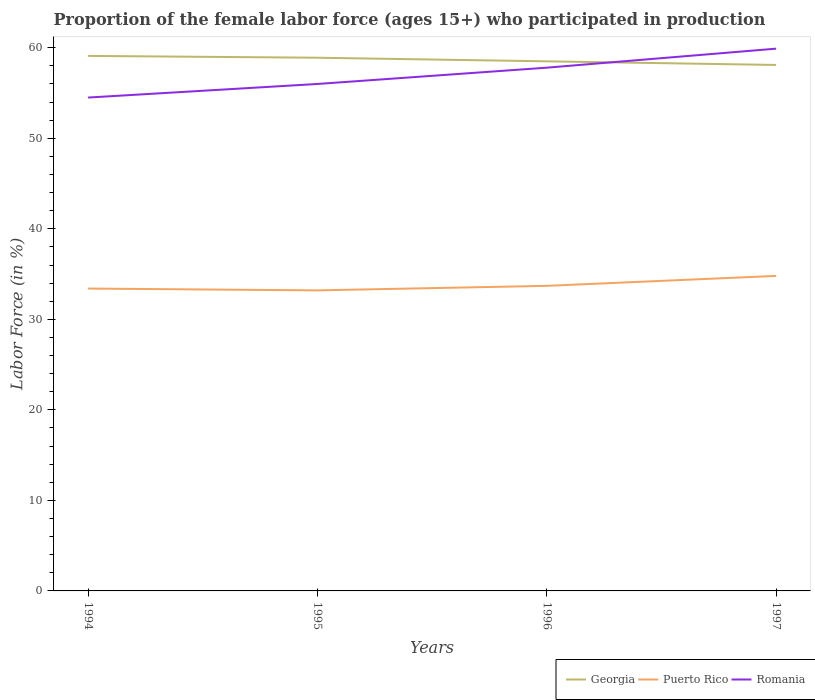Is the number of lines equal to the number of legend labels?
Offer a terse response. Yes. Across all years, what is the maximum proportion of the female labor force who participated in production in Puerto Rico?
Ensure brevity in your answer.  33.2. What is the total proportion of the female labor force who participated in production in Puerto Rico in the graph?
Ensure brevity in your answer.  -1.1. What is the difference between the highest and the second highest proportion of the female labor force who participated in production in Georgia?
Offer a terse response. 1. What is the difference between the highest and the lowest proportion of the female labor force who participated in production in Puerto Rico?
Ensure brevity in your answer.  1. Is the proportion of the female labor force who participated in production in Puerto Rico strictly greater than the proportion of the female labor force who participated in production in Georgia over the years?
Give a very brief answer. Yes. How many lines are there?
Provide a succinct answer. 3. What is the difference between two consecutive major ticks on the Y-axis?
Provide a short and direct response. 10. Are the values on the major ticks of Y-axis written in scientific E-notation?
Your answer should be compact. No. Does the graph contain any zero values?
Ensure brevity in your answer.  No. Does the graph contain grids?
Give a very brief answer. No. Where does the legend appear in the graph?
Ensure brevity in your answer.  Bottom right. How many legend labels are there?
Your response must be concise. 3. What is the title of the graph?
Your answer should be compact. Proportion of the female labor force (ages 15+) who participated in production. What is the Labor Force (in %) in Georgia in 1994?
Give a very brief answer. 59.1. What is the Labor Force (in %) of Puerto Rico in 1994?
Give a very brief answer. 33.4. What is the Labor Force (in %) of Romania in 1994?
Keep it short and to the point. 54.5. What is the Labor Force (in %) of Georgia in 1995?
Ensure brevity in your answer.  58.9. What is the Labor Force (in %) of Puerto Rico in 1995?
Offer a very short reply. 33.2. What is the Labor Force (in %) in Georgia in 1996?
Make the answer very short. 58.5. What is the Labor Force (in %) in Puerto Rico in 1996?
Ensure brevity in your answer.  33.7. What is the Labor Force (in %) of Romania in 1996?
Keep it short and to the point. 57.8. What is the Labor Force (in %) of Georgia in 1997?
Your answer should be compact. 58.1. What is the Labor Force (in %) in Puerto Rico in 1997?
Offer a very short reply. 34.8. What is the Labor Force (in %) of Romania in 1997?
Offer a very short reply. 59.9. Across all years, what is the maximum Labor Force (in %) in Georgia?
Your answer should be compact. 59.1. Across all years, what is the maximum Labor Force (in %) in Puerto Rico?
Keep it short and to the point. 34.8. Across all years, what is the maximum Labor Force (in %) in Romania?
Make the answer very short. 59.9. Across all years, what is the minimum Labor Force (in %) in Georgia?
Keep it short and to the point. 58.1. Across all years, what is the minimum Labor Force (in %) in Puerto Rico?
Your response must be concise. 33.2. Across all years, what is the minimum Labor Force (in %) in Romania?
Provide a short and direct response. 54.5. What is the total Labor Force (in %) in Georgia in the graph?
Give a very brief answer. 234.6. What is the total Labor Force (in %) in Puerto Rico in the graph?
Offer a very short reply. 135.1. What is the total Labor Force (in %) in Romania in the graph?
Your answer should be very brief. 228.2. What is the difference between the Labor Force (in %) of Puerto Rico in 1994 and that in 1997?
Your answer should be very brief. -1.4. What is the difference between the Labor Force (in %) in Georgia in 1995 and that in 1996?
Your answer should be very brief. 0.4. What is the difference between the Labor Force (in %) in Puerto Rico in 1995 and that in 1996?
Make the answer very short. -0.5. What is the difference between the Labor Force (in %) in Romania in 1995 and that in 1996?
Keep it short and to the point. -1.8. What is the difference between the Labor Force (in %) in Puerto Rico in 1995 and that in 1997?
Your response must be concise. -1.6. What is the difference between the Labor Force (in %) in Romania in 1995 and that in 1997?
Provide a succinct answer. -3.9. What is the difference between the Labor Force (in %) of Georgia in 1994 and the Labor Force (in %) of Puerto Rico in 1995?
Offer a terse response. 25.9. What is the difference between the Labor Force (in %) of Georgia in 1994 and the Labor Force (in %) of Romania in 1995?
Provide a succinct answer. 3.1. What is the difference between the Labor Force (in %) in Puerto Rico in 1994 and the Labor Force (in %) in Romania in 1995?
Provide a short and direct response. -22.6. What is the difference between the Labor Force (in %) of Georgia in 1994 and the Labor Force (in %) of Puerto Rico in 1996?
Offer a terse response. 25.4. What is the difference between the Labor Force (in %) of Georgia in 1994 and the Labor Force (in %) of Romania in 1996?
Your answer should be very brief. 1.3. What is the difference between the Labor Force (in %) of Puerto Rico in 1994 and the Labor Force (in %) of Romania in 1996?
Make the answer very short. -24.4. What is the difference between the Labor Force (in %) in Georgia in 1994 and the Labor Force (in %) in Puerto Rico in 1997?
Your answer should be very brief. 24.3. What is the difference between the Labor Force (in %) of Georgia in 1994 and the Labor Force (in %) of Romania in 1997?
Your answer should be compact. -0.8. What is the difference between the Labor Force (in %) in Puerto Rico in 1994 and the Labor Force (in %) in Romania in 1997?
Provide a short and direct response. -26.5. What is the difference between the Labor Force (in %) in Georgia in 1995 and the Labor Force (in %) in Puerto Rico in 1996?
Your response must be concise. 25.2. What is the difference between the Labor Force (in %) in Georgia in 1995 and the Labor Force (in %) in Romania in 1996?
Offer a very short reply. 1.1. What is the difference between the Labor Force (in %) of Puerto Rico in 1995 and the Labor Force (in %) of Romania in 1996?
Keep it short and to the point. -24.6. What is the difference between the Labor Force (in %) in Georgia in 1995 and the Labor Force (in %) in Puerto Rico in 1997?
Your answer should be very brief. 24.1. What is the difference between the Labor Force (in %) in Georgia in 1995 and the Labor Force (in %) in Romania in 1997?
Make the answer very short. -1. What is the difference between the Labor Force (in %) in Puerto Rico in 1995 and the Labor Force (in %) in Romania in 1997?
Your response must be concise. -26.7. What is the difference between the Labor Force (in %) in Georgia in 1996 and the Labor Force (in %) in Puerto Rico in 1997?
Your response must be concise. 23.7. What is the difference between the Labor Force (in %) in Puerto Rico in 1996 and the Labor Force (in %) in Romania in 1997?
Offer a very short reply. -26.2. What is the average Labor Force (in %) of Georgia per year?
Your response must be concise. 58.65. What is the average Labor Force (in %) of Puerto Rico per year?
Ensure brevity in your answer.  33.77. What is the average Labor Force (in %) in Romania per year?
Give a very brief answer. 57.05. In the year 1994, what is the difference between the Labor Force (in %) in Georgia and Labor Force (in %) in Puerto Rico?
Offer a very short reply. 25.7. In the year 1994, what is the difference between the Labor Force (in %) in Georgia and Labor Force (in %) in Romania?
Provide a succinct answer. 4.6. In the year 1994, what is the difference between the Labor Force (in %) in Puerto Rico and Labor Force (in %) in Romania?
Make the answer very short. -21.1. In the year 1995, what is the difference between the Labor Force (in %) of Georgia and Labor Force (in %) of Puerto Rico?
Your response must be concise. 25.7. In the year 1995, what is the difference between the Labor Force (in %) of Georgia and Labor Force (in %) of Romania?
Your answer should be very brief. 2.9. In the year 1995, what is the difference between the Labor Force (in %) in Puerto Rico and Labor Force (in %) in Romania?
Offer a terse response. -22.8. In the year 1996, what is the difference between the Labor Force (in %) of Georgia and Labor Force (in %) of Puerto Rico?
Your answer should be compact. 24.8. In the year 1996, what is the difference between the Labor Force (in %) of Georgia and Labor Force (in %) of Romania?
Keep it short and to the point. 0.7. In the year 1996, what is the difference between the Labor Force (in %) of Puerto Rico and Labor Force (in %) of Romania?
Offer a terse response. -24.1. In the year 1997, what is the difference between the Labor Force (in %) in Georgia and Labor Force (in %) in Puerto Rico?
Provide a short and direct response. 23.3. In the year 1997, what is the difference between the Labor Force (in %) in Georgia and Labor Force (in %) in Romania?
Offer a very short reply. -1.8. In the year 1997, what is the difference between the Labor Force (in %) in Puerto Rico and Labor Force (in %) in Romania?
Your answer should be very brief. -25.1. What is the ratio of the Labor Force (in %) in Georgia in 1994 to that in 1995?
Your answer should be very brief. 1. What is the ratio of the Labor Force (in %) of Romania in 1994 to that in 1995?
Ensure brevity in your answer.  0.97. What is the ratio of the Labor Force (in %) in Georgia in 1994 to that in 1996?
Provide a short and direct response. 1.01. What is the ratio of the Labor Force (in %) in Puerto Rico in 1994 to that in 1996?
Your answer should be compact. 0.99. What is the ratio of the Labor Force (in %) in Romania in 1994 to that in 1996?
Keep it short and to the point. 0.94. What is the ratio of the Labor Force (in %) in Georgia in 1994 to that in 1997?
Keep it short and to the point. 1.02. What is the ratio of the Labor Force (in %) of Puerto Rico in 1994 to that in 1997?
Make the answer very short. 0.96. What is the ratio of the Labor Force (in %) in Romania in 1994 to that in 1997?
Provide a succinct answer. 0.91. What is the ratio of the Labor Force (in %) in Georgia in 1995 to that in 1996?
Make the answer very short. 1.01. What is the ratio of the Labor Force (in %) of Puerto Rico in 1995 to that in 1996?
Your answer should be very brief. 0.99. What is the ratio of the Labor Force (in %) in Romania in 1995 to that in 1996?
Your response must be concise. 0.97. What is the ratio of the Labor Force (in %) of Georgia in 1995 to that in 1997?
Provide a short and direct response. 1.01. What is the ratio of the Labor Force (in %) of Puerto Rico in 1995 to that in 1997?
Keep it short and to the point. 0.95. What is the ratio of the Labor Force (in %) in Romania in 1995 to that in 1997?
Give a very brief answer. 0.93. What is the ratio of the Labor Force (in %) in Georgia in 1996 to that in 1997?
Offer a very short reply. 1.01. What is the ratio of the Labor Force (in %) in Puerto Rico in 1996 to that in 1997?
Your answer should be very brief. 0.97. What is the ratio of the Labor Force (in %) in Romania in 1996 to that in 1997?
Give a very brief answer. 0.96. What is the difference between the highest and the lowest Labor Force (in %) in Puerto Rico?
Your answer should be very brief. 1.6. 